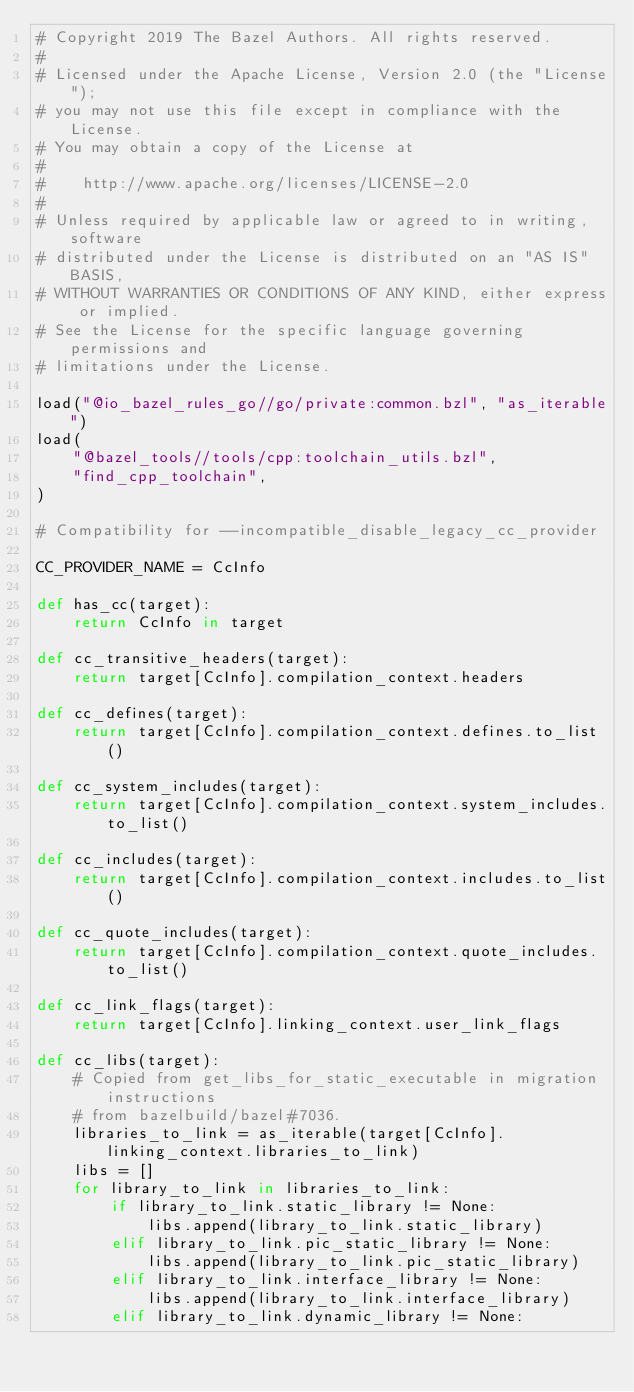Convert code to text. <code><loc_0><loc_0><loc_500><loc_500><_Python_># Copyright 2019 The Bazel Authors. All rights reserved.
#
# Licensed under the Apache License, Version 2.0 (the "License");
# you may not use this file except in compliance with the License.
# You may obtain a copy of the License at
#
#    http://www.apache.org/licenses/LICENSE-2.0
#
# Unless required by applicable law or agreed to in writing, software
# distributed under the License is distributed on an "AS IS" BASIS,
# WITHOUT WARRANTIES OR CONDITIONS OF ANY KIND, either express or implied.
# See the License for the specific language governing permissions and
# limitations under the License.

load("@io_bazel_rules_go//go/private:common.bzl", "as_iterable")
load(
    "@bazel_tools//tools/cpp:toolchain_utils.bzl",
    "find_cpp_toolchain",
)

# Compatibility for --incompatible_disable_legacy_cc_provider

CC_PROVIDER_NAME = CcInfo

def has_cc(target):
    return CcInfo in target

def cc_transitive_headers(target):
    return target[CcInfo].compilation_context.headers

def cc_defines(target):
    return target[CcInfo].compilation_context.defines.to_list()

def cc_system_includes(target):
    return target[CcInfo].compilation_context.system_includes.to_list()

def cc_includes(target):
    return target[CcInfo].compilation_context.includes.to_list()

def cc_quote_includes(target):
    return target[CcInfo].compilation_context.quote_includes.to_list()

def cc_link_flags(target):
    return target[CcInfo].linking_context.user_link_flags

def cc_libs(target):
    # Copied from get_libs_for_static_executable in migration instructions
    # from bazelbuild/bazel#7036.
    libraries_to_link = as_iterable(target[CcInfo].linking_context.libraries_to_link)
    libs = []
    for library_to_link in libraries_to_link:
        if library_to_link.static_library != None:
            libs.append(library_to_link.static_library)
        elif library_to_link.pic_static_library != None:
            libs.append(library_to_link.pic_static_library)
        elif library_to_link.interface_library != None:
            libs.append(library_to_link.interface_library)
        elif library_to_link.dynamic_library != None:</code> 